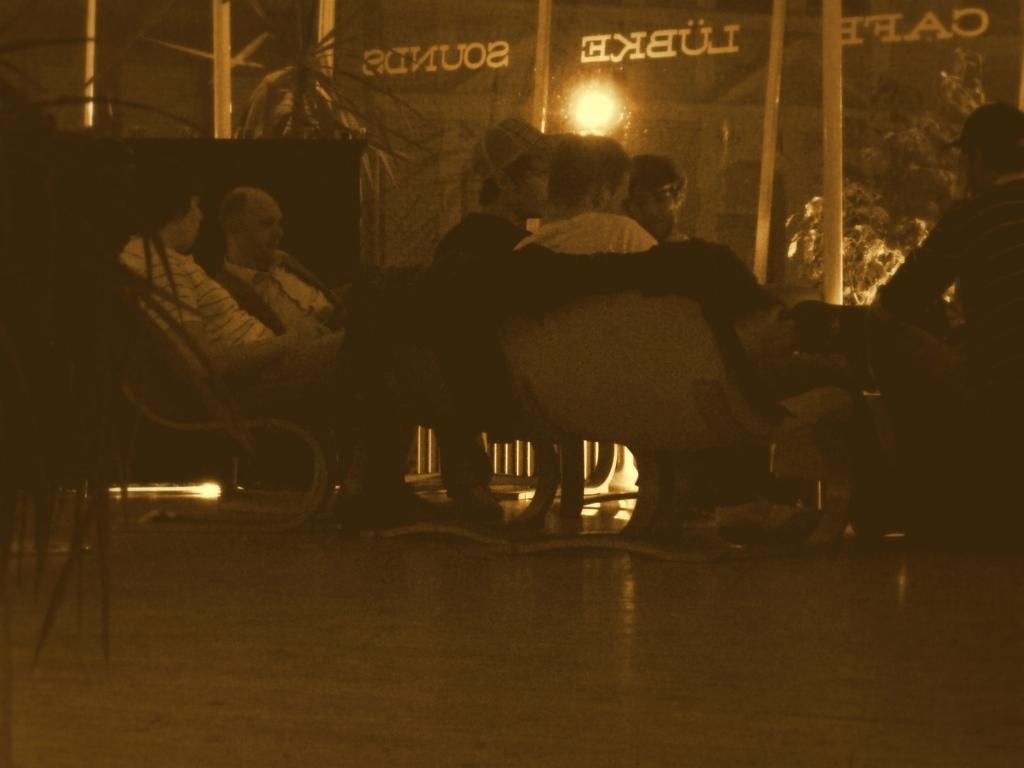What type of view is shown in the image? The image shows the inner view of a building. What are the people in the image doing? There are people sitting on chairs in the image. What type of vegetation is present in the image? There is a tree and plants in the image. What can be used for illumination in the image? There is a light in the image. What type of structure is visible in the image? There is a building visible in the image. What is present on the glass wall in the image? There is text on a glass wall in the image. How does the person in the image drive a car while sitting on the chair? There is no person driving a car in the image; they are sitting on chairs inside a building. What type of twist can be seen in the image? There is no twist present in the image; it shows a straightforward view of the building's interior. 